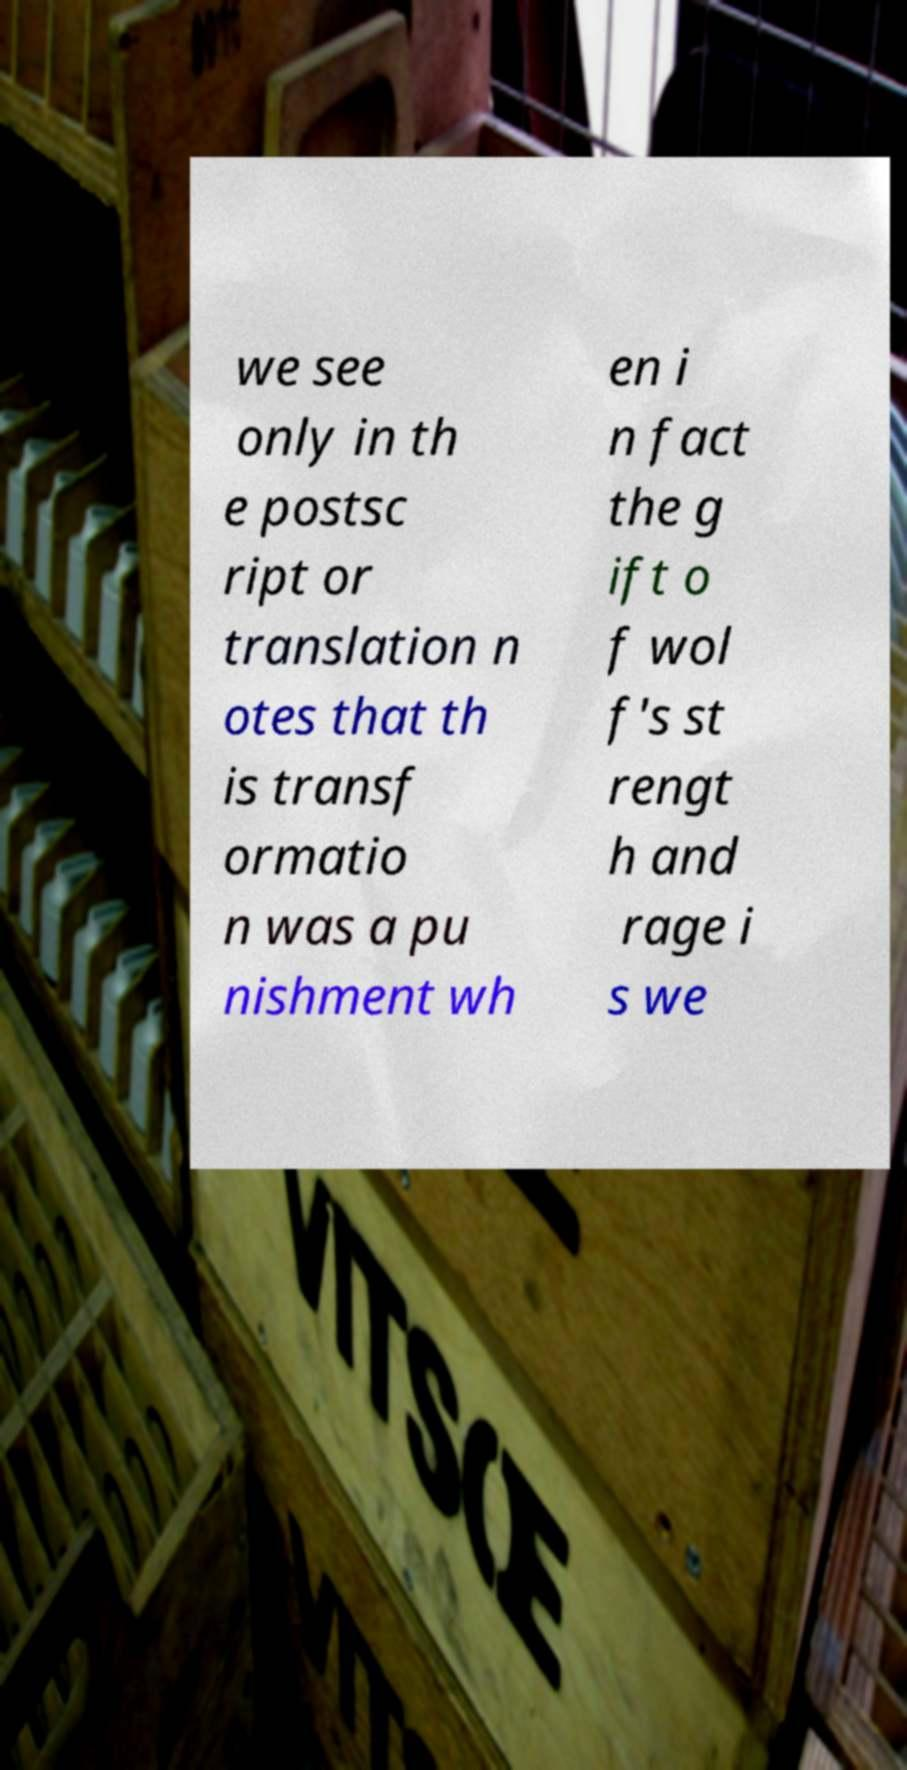What messages or text are displayed in this image? I need them in a readable, typed format. we see only in th e postsc ript or translation n otes that th is transf ormatio n was a pu nishment wh en i n fact the g ift o f wol f's st rengt h and rage i s we 